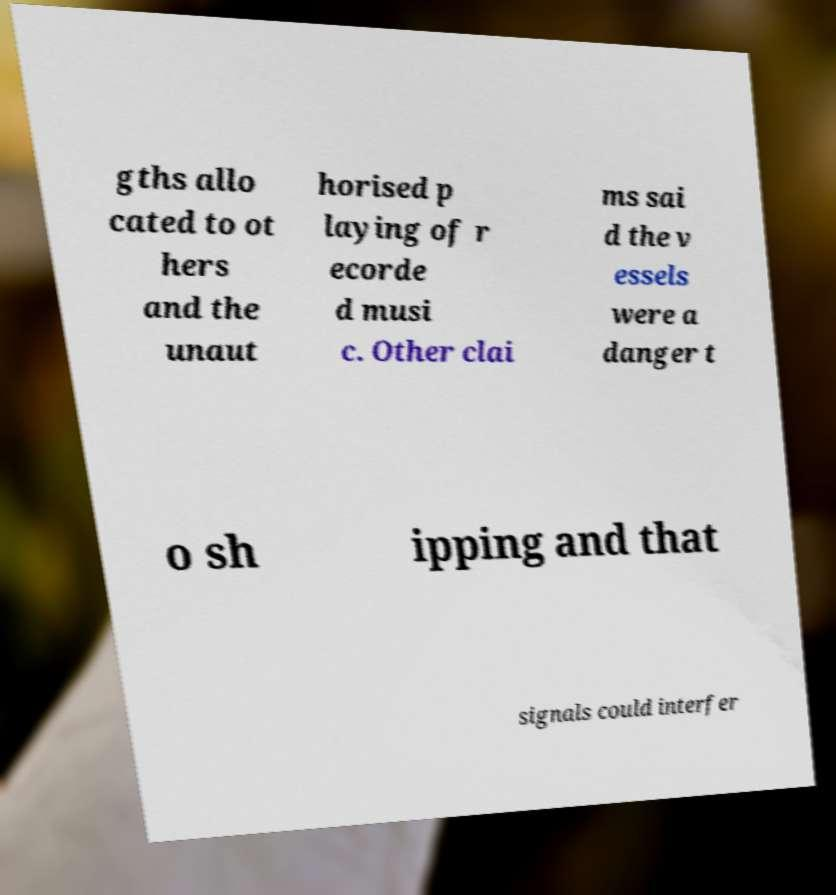Please identify and transcribe the text found in this image. gths allo cated to ot hers and the unaut horised p laying of r ecorde d musi c. Other clai ms sai d the v essels were a danger t o sh ipping and that signals could interfer 